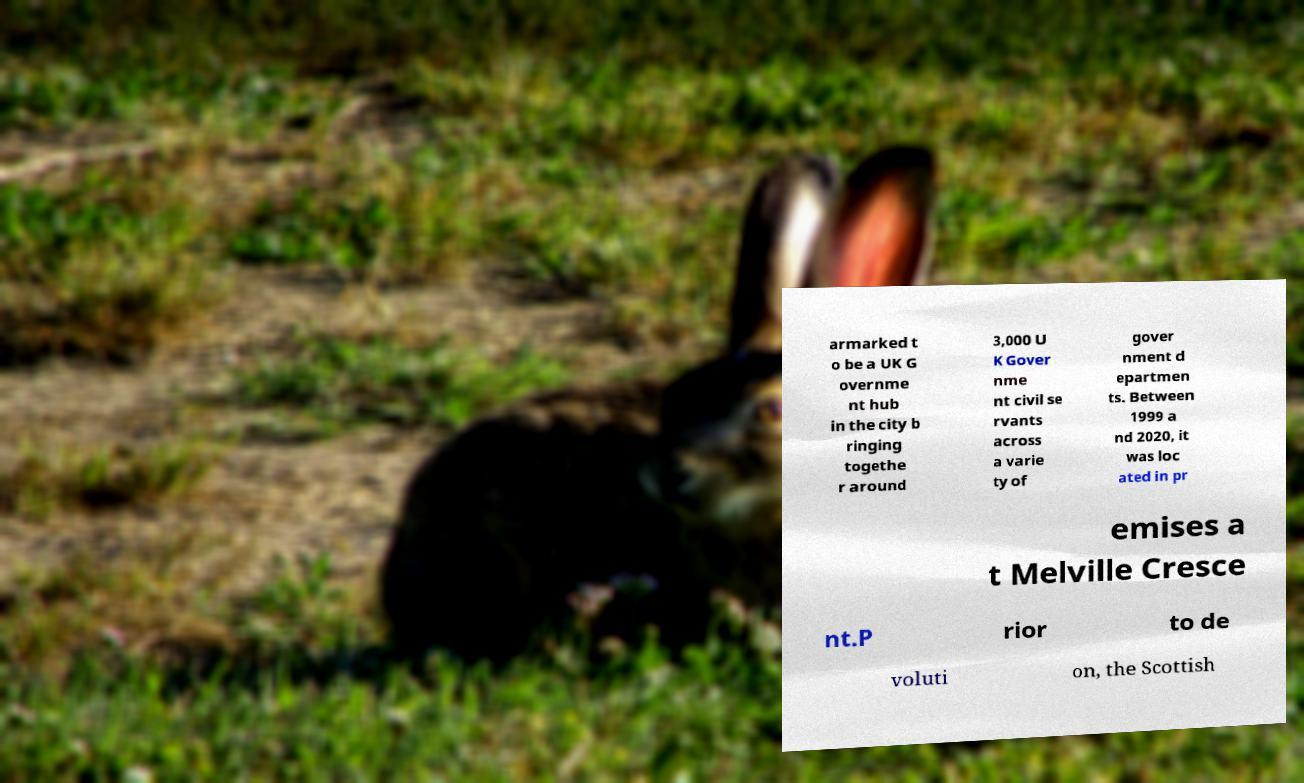Can you accurately transcribe the text from the provided image for me? armarked t o be a UK G overnme nt hub in the city b ringing togethe r around 3,000 U K Gover nme nt civil se rvants across a varie ty of gover nment d epartmen ts. Between 1999 a nd 2020, it was loc ated in pr emises a t Melville Cresce nt.P rior to de voluti on, the Scottish 